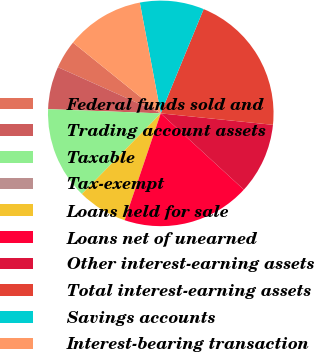Convert chart to OTSL. <chart><loc_0><loc_0><loc_500><loc_500><pie_chart><fcel>Federal funds sold and<fcel>Trading account assets<fcel>Taxable<fcel>Tax-exempt<fcel>Loans held for sale<fcel>Loans net of unearned<fcel>Other interest-earning assets<fcel>Total interest-earning assets<fcel>Savings accounts<fcel>Interest-bearing transaction<nl><fcel>4.08%<fcel>6.12%<fcel>13.26%<fcel>0.0%<fcel>7.14%<fcel>18.36%<fcel>10.2%<fcel>20.4%<fcel>9.18%<fcel>11.22%<nl></chart> 